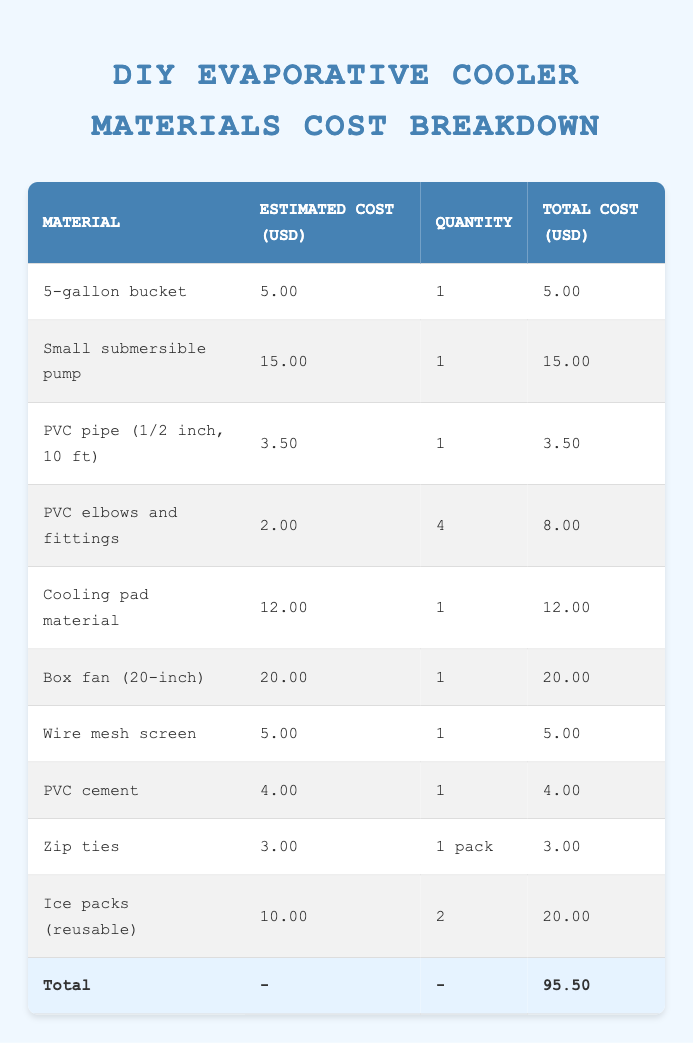What is the total cost of materials to build a DIY evaporative cooler? The total cost is found in the last row of the table, under "Total Cost (USD)," which shows 95.50.
Answer: 95.50 How much does a small submersible pump cost? This information is located in the second row under "Estimated Cost (USD)," which shows a cost of 15.00 for the small submersible pump.
Answer: 15.00 What is the total cost for the ice packs? The table shows that the ice packs are listed with a unit cost of 10.00 and a quantity of 2. Total cost can be calculated by multiplying these values: 10.00 x 2 = 20.00.
Answer: 20.00 Are the PVC elbows and fittings more expensive than the wire mesh screen? The cost for PVC elbows and fittings is 8.00 while the wire mesh screen is priced at 5.00. Since 8.00 is greater than 5.00, the statement is true.
Answer: Yes What is the cheapest material listed in the table? By examining each total cost in the table, the cheapest item is the PVC cement at a cost of 4.00.
Answer: 4.00 What would be the total cost if we purchased one additional box fan? The cost of a box fan is 20.00. Adding another box fan to the total cost of 95.50 gives: 95.50 + 20.00 = 115.50.
Answer: 115.50 How many materials listed are cheaper than 10.00? The materials below 10.00 in the table are the 5-gallon bucket (5.00), PVC pipe (3.50), PVC elbows and fittings (2.00), wire mesh screen (5.00), PVC cement (4.00), and zip ties (3.00). This results in a total of 6 materials.
Answer: 6 What is the average cost of all materials listed? To calculate the average, sum up all total costs: 5.00 + 15.00 + 3.50 + 8.00 + 12.00 + 20.00 + 5.00 + 4.00 + 3.00 + 20.00 = 95.50. Divide by the number of items (10): 95.50 / 10 = 9.55.
Answer: 9.55 Is the total cost of the cooling pad material equal to the total cost of the ice packs? The cooling pad material costs 12.00, while the ice packs cost 20.00. Since they are not equal (12.00 is not equal to 20.00), the answer is false.
Answer: No 